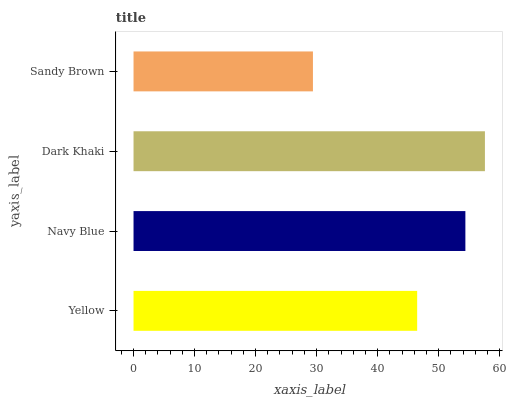Is Sandy Brown the minimum?
Answer yes or no. Yes. Is Dark Khaki the maximum?
Answer yes or no. Yes. Is Navy Blue the minimum?
Answer yes or no. No. Is Navy Blue the maximum?
Answer yes or no. No. Is Navy Blue greater than Yellow?
Answer yes or no. Yes. Is Yellow less than Navy Blue?
Answer yes or no. Yes. Is Yellow greater than Navy Blue?
Answer yes or no. No. Is Navy Blue less than Yellow?
Answer yes or no. No. Is Navy Blue the high median?
Answer yes or no. Yes. Is Yellow the low median?
Answer yes or no. Yes. Is Yellow the high median?
Answer yes or no. No. Is Sandy Brown the low median?
Answer yes or no. No. 